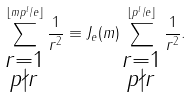<formula> <loc_0><loc_0><loc_500><loc_500>\sum _ { \substack { r = 1 \\ p \nmid r } } ^ { \lfloor m p ^ { l } / e \rfloor } \frac { 1 } { r ^ { 2 } } \equiv J _ { e } ( m ) \sum _ { \substack { r = 1 \\ p \nmid r } } ^ { \lfloor p ^ { l } / e \rfloor } \frac { 1 } { r ^ { 2 } } .</formula> 